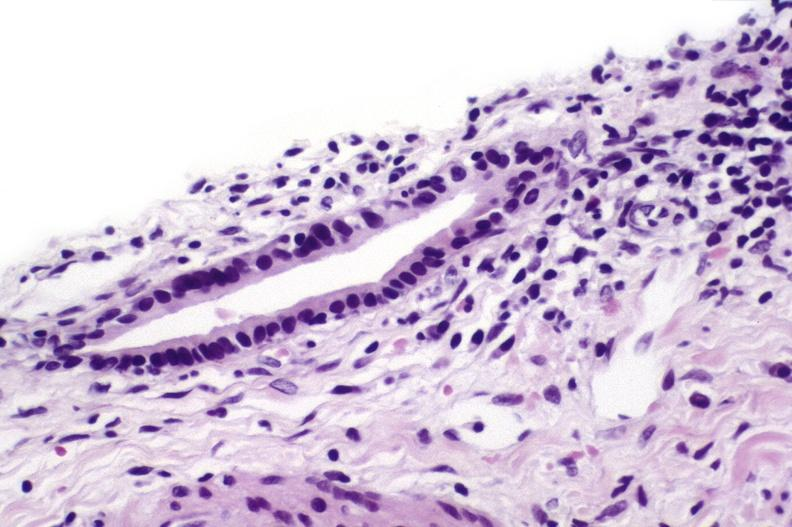s hepatobiliary present?
Answer the question using a single word or phrase. Yes 